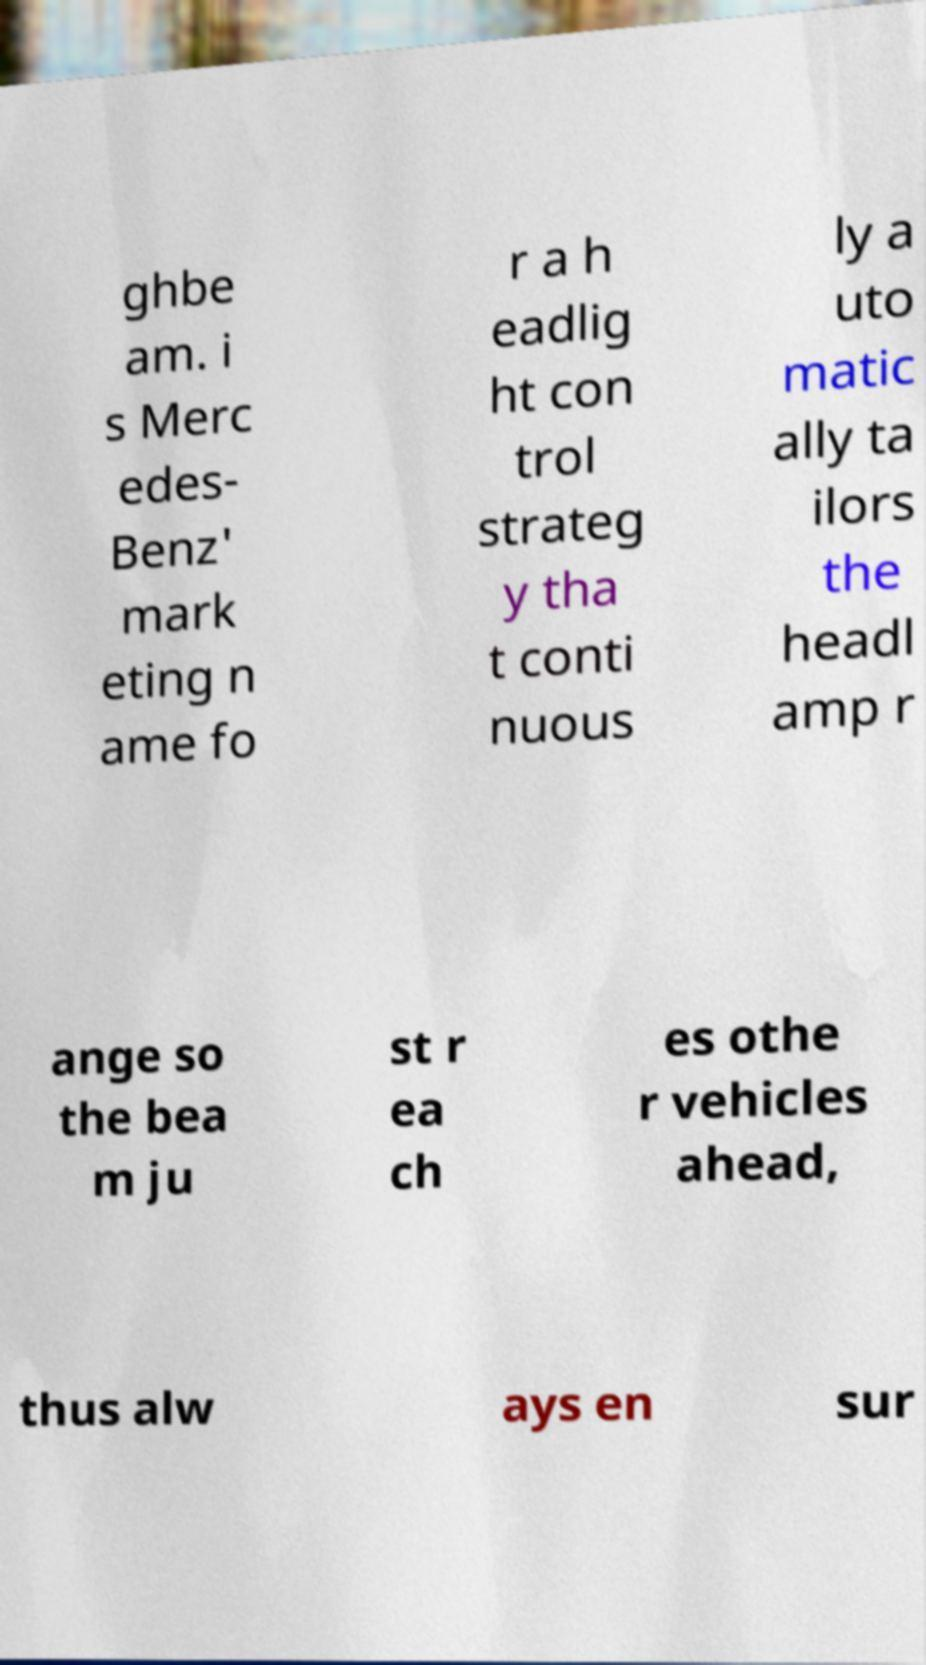Could you assist in decoding the text presented in this image and type it out clearly? ghbe am. i s Merc edes- Benz' mark eting n ame fo r a h eadlig ht con trol strateg y tha t conti nuous ly a uto matic ally ta ilors the headl amp r ange so the bea m ju st r ea ch es othe r vehicles ahead, thus alw ays en sur 